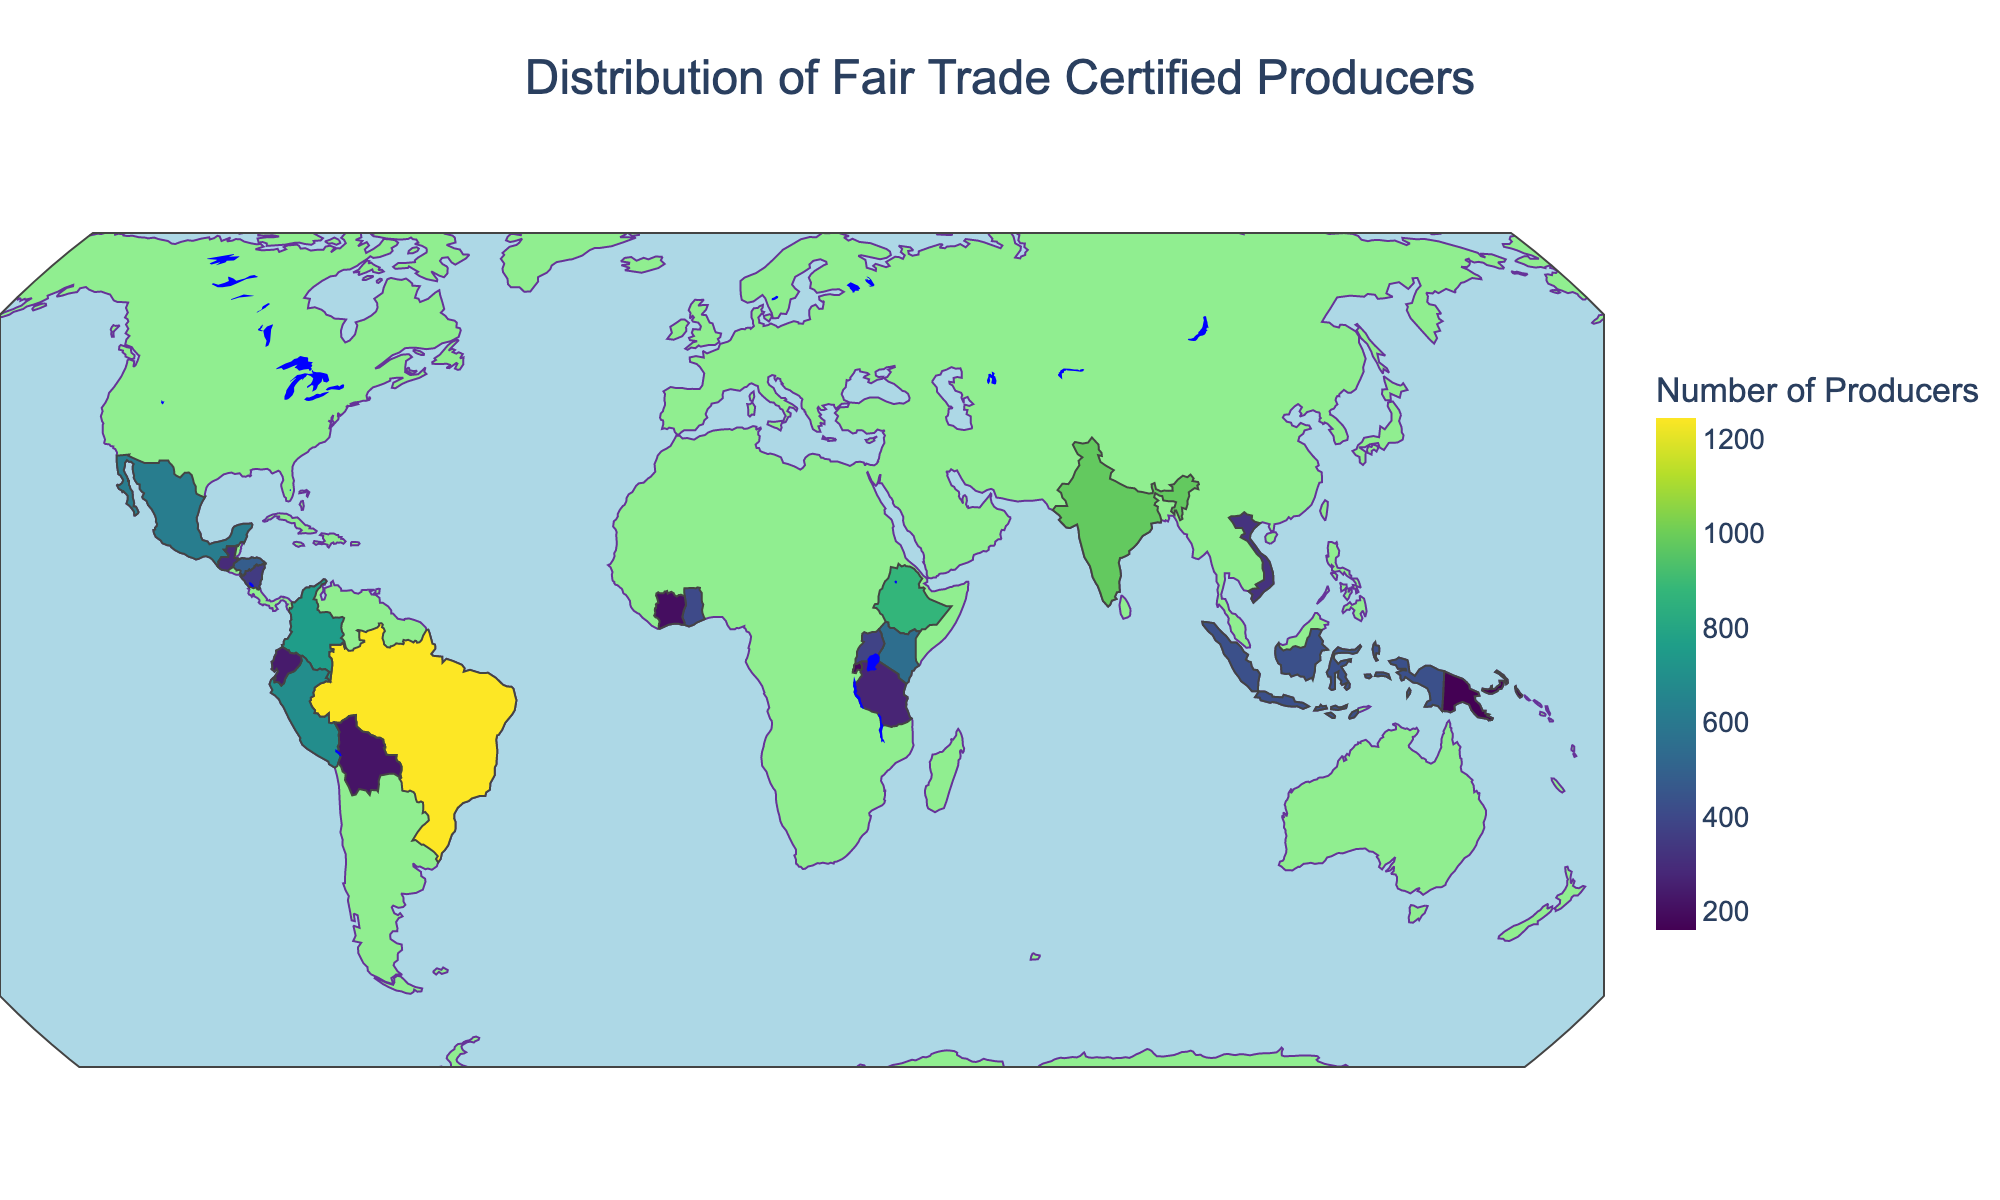What's the title of the figure? The title is placed prominently at the top of the figure. It helps provide context about what the figure represents.
Answer: Distribution of Fair Trade Certified Producers How is the color gradient used in the figure? The color gradient represents the number of Fair Trade Certified Producers in each country. Darker shades indicate higher numbers, while lighter shades indicate lower numbers.
Answer: To show the number of Producers Which country has the highest number of Fair Trade Certified Producers? By examining the color intensity and the hover information on the map, Brazil appears to be the darkest, indicating the highest number of producers.
Answer: Brazil What is the number of Fair Trade Certified Producers in India? India can be located on the map using its geographical location. Hovering over India reveals the exact number of producers.
Answer: 980 How many producers are there in Ghana and Vietnam combined? Find Ghana and Vietnam on the map, hover over each, and sum their respective producer counts (Ghana: 405 and Vietnam: 320).
Answer: 725 Which country has fewer producers: Mexico or Colombia? Locate both countries on the map, hover over them to get the exact counts, and compare them (Mexico: 620, Colombia: 760).
Answer: Mexico What is the difference in the number of producers between Ethiopia and Kenya? Hover over Ethiopia and Kenya on the map, then subtract the smaller number from the larger one (Ethiopia: 875, Kenya: 550).
Answer: 325 Are there more Fair Trade Certified Producers in Uganda or Rwanda? Uganda and Rwanda can be found on the map, and the hover information will show that Uganda has 380 producers, and Rwanda has 180.
Answer: Uganda Which region (Central America or Southeast Asia) has a higher total number of producers? (Consider Nicaragua, Honduras, and Guatemala for Central America; Vietnam and Indonesia for Southeast Asia) Sum the producers in each region. Central America: Nicaragua (350) + Honduras (480) + Guatemala (290) = 1120; Southeast Asia: Vietnam (320) + Indonesia (430) = 750.
Answer: Central America Which continent appears to have the most Fair Trade Certified Producers based on the map? By inspecting the distribution on the map, it can be seen that South America has a high concentration of dark-shaded countries like Brazil, Colombia, and Peru.
Answer: South America 